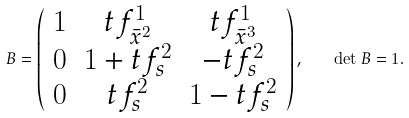Convert formula to latex. <formula><loc_0><loc_0><loc_500><loc_500>B = \left ( \begin{array} { c c c } 1 & t f ^ { 1 } _ { \bar { x } ^ { 2 } } & t f ^ { 1 } _ { \bar { x } ^ { 3 } } \\ 0 & 1 + t f ^ { 2 } _ { s } & - t f ^ { 2 } _ { s } \\ 0 & t f ^ { 2 } _ { s } & 1 - t f ^ { 2 } _ { s } \end{array} \right ) , \quad \det { B } = 1 .</formula> 